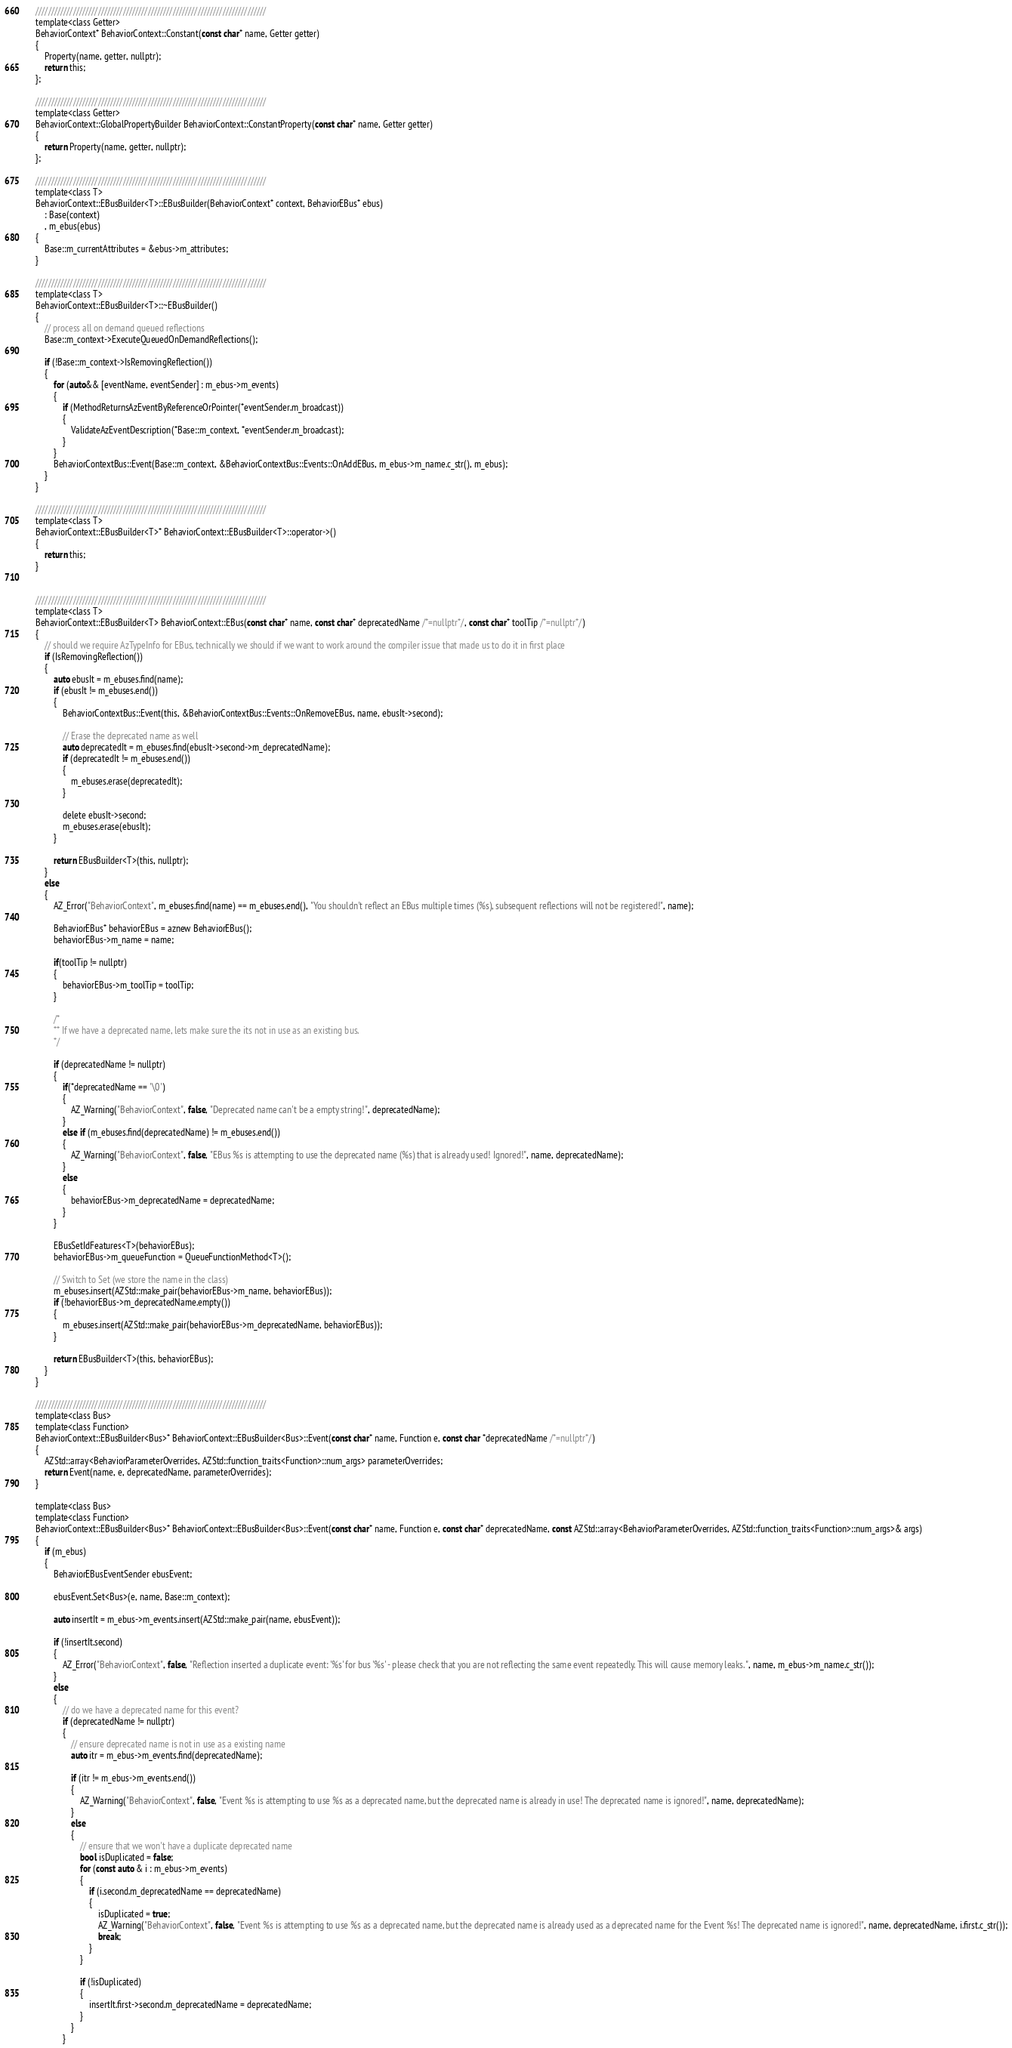Convert code to text. <code><loc_0><loc_0><loc_500><loc_500><_C_>
    //////////////////////////////////////////////////////////////////////////
    template<class Getter>
    BehaviorContext* BehaviorContext::Constant(const char* name, Getter getter)
    {
        Property(name, getter, nullptr);
        return this;
    };

    //////////////////////////////////////////////////////////////////////////
    template<class Getter>
    BehaviorContext::GlobalPropertyBuilder BehaviorContext::ConstantProperty(const char* name, Getter getter)
    {
        return Property(name, getter, nullptr);
    };

    //////////////////////////////////////////////////////////////////////////
    template<class T>
    BehaviorContext::EBusBuilder<T>::EBusBuilder(BehaviorContext* context, BehaviorEBus* ebus)
        : Base(context)
        , m_ebus(ebus)
    {
        Base::m_currentAttributes = &ebus->m_attributes;
    }

    //////////////////////////////////////////////////////////////////////////
    template<class T>
    BehaviorContext::EBusBuilder<T>::~EBusBuilder()
    {
        // process all on demand queued reflections
        Base::m_context->ExecuteQueuedOnDemandReflections();

        if (!Base::m_context->IsRemovingReflection())
        {
            for (auto&& [eventName, eventSender] : m_ebus->m_events)
            {
                if (MethodReturnsAzEventByReferenceOrPointer(*eventSender.m_broadcast))
                {
                    ValidateAzEventDescription(*Base::m_context, *eventSender.m_broadcast);
                }
            }
            BehaviorContextBus::Event(Base::m_context, &BehaviorContextBus::Events::OnAddEBus, m_ebus->m_name.c_str(), m_ebus);
        }
    }

    //////////////////////////////////////////////////////////////////////////
    template<class T>
    BehaviorContext::EBusBuilder<T>* BehaviorContext::EBusBuilder<T>::operator->()
    {
        return this;
    }

   
    //////////////////////////////////////////////////////////////////////////
    template<class T>
    BehaviorContext::EBusBuilder<T> BehaviorContext::EBus(const char* name, const char* deprecatedName /*=nullptr*/, const char* toolTip /*=nullptr*/)
    {
        // should we require AzTypeInfo for EBus, technically we should if we want to work around the compiler issue that made us to do it in first place
        if (IsRemovingReflection())
        {
            auto ebusIt = m_ebuses.find(name);
            if (ebusIt != m_ebuses.end())
            {
                BehaviorContextBus::Event(this, &BehaviorContextBus::Events::OnRemoveEBus, name, ebusIt->second);

                // Erase the deprecated name as well
                auto deprecatedIt = m_ebuses.find(ebusIt->second->m_deprecatedName);
                if (deprecatedIt != m_ebuses.end())
                {
                    m_ebuses.erase(deprecatedIt);
                }

                delete ebusIt->second;
                m_ebuses.erase(ebusIt);
            }

            return EBusBuilder<T>(this, nullptr);
        }
        else
        {
            AZ_Error("BehaviorContext", m_ebuses.find(name) == m_ebuses.end(), "You shouldn't reflect an EBus multiple times (%s), subsequent reflections will not be registered!", name);

            BehaviorEBus* behaviorEBus = aznew BehaviorEBus();
            behaviorEBus->m_name = name;

            if(toolTip != nullptr)
            {
                behaviorEBus->m_toolTip = toolTip;
            }

            /*
            ** If we have a deprecated name, lets make sure the its not in use as an existing bus.
            */

            if (deprecatedName != nullptr)
            {
                if(*deprecatedName == '\0')
                {
                    AZ_Warning("BehaviorContext", false, "Deprecated name can't be a empty string!", deprecatedName);
                }
                else if (m_ebuses.find(deprecatedName) != m_ebuses.end())
                {
                    AZ_Warning("BehaviorContext", false, "EBus %s is attempting to use the deprecated name (%s) that is already used! Ignored!", name, deprecatedName);
                }
                else
                {
                    behaviorEBus->m_deprecatedName = deprecatedName;
                }
            }

            EBusSetIdFeatures<T>(behaviorEBus);
            behaviorEBus->m_queueFunction = QueueFunctionMethod<T>();

            // Switch to Set (we store the name in the class)
            m_ebuses.insert(AZStd::make_pair(behaviorEBus->m_name, behaviorEBus));
            if (!behaviorEBus->m_deprecatedName.empty())
            {
                m_ebuses.insert(AZStd::make_pair(behaviorEBus->m_deprecatedName, behaviorEBus));
            }

            return EBusBuilder<T>(this, behaviorEBus);
        }
    }

    //////////////////////////////////////////////////////////////////////////
    template<class Bus>
    template<class Function>
    BehaviorContext::EBusBuilder<Bus>* BehaviorContext::EBusBuilder<Bus>::Event(const char* name, Function e, const char *deprecatedName /*=nullptr*/)
    {
        AZStd::array<BehaviorParameterOverrides, AZStd::function_traits<Function>::num_args> parameterOverrides;
        return Event(name, e, deprecatedName, parameterOverrides);
    }

    template<class Bus>
    template<class Function>
    BehaviorContext::EBusBuilder<Bus>* BehaviorContext::EBusBuilder<Bus>::Event(const char* name, Function e, const char* deprecatedName, const AZStd::array<BehaviorParameterOverrides, AZStd::function_traits<Function>::num_args>& args)
    {
        if (m_ebus)
        {
            BehaviorEBusEventSender ebusEvent;

            ebusEvent.Set<Bus>(e, name, Base::m_context);

            auto insertIt = m_ebus->m_events.insert(AZStd::make_pair(name, ebusEvent));

            if (!insertIt.second)
            {
                AZ_Error("BehaviorContext", false, "Reflection inserted a duplicate event: '%s' for bus '%s' - please check that you are not reflecting the same event repeatedly. This will cause memory leaks.", name, m_ebus->m_name.c_str());
            }
            else
            {
                // do we have a deprecated name for this event?
                if (deprecatedName != nullptr)
                {
                    // ensure deprecated name is not in use as a existing name
                    auto itr = m_ebus->m_events.find(deprecatedName);

                    if (itr != m_ebus->m_events.end())
                    {
                        AZ_Warning("BehaviorContext", false, "Event %s is attempting to use %s as a deprecated name, but the deprecated name is already in use! The deprecated name is ignored!", name, deprecatedName);
                    }
                    else
                    {
                        // ensure that we won't have a duplicate deprecated name
                        bool isDuplicated = false;
                        for (const auto & i : m_ebus->m_events)
                        {
                            if (i.second.m_deprecatedName == deprecatedName)
                            {
                                isDuplicated = true;
                                AZ_Warning("BehaviorContext", false, "Event %s is attempting to use %s as a deprecated name, but the deprecated name is already used as a deprecated name for the Event %s! The deprecated name is ignored!", name, deprecatedName, i.first.c_str());
                                break;
                            }
                        }

                        if (!isDuplicated)
                        {
                            insertIt.first->second.m_deprecatedName = deprecatedName;
                        }
                    }
                }
</code> 